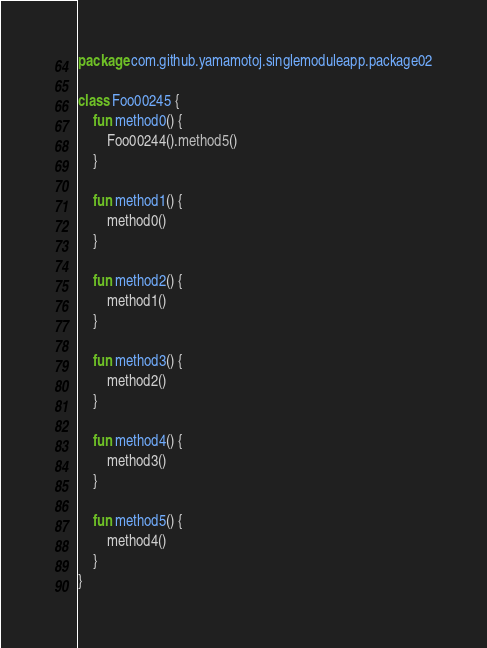Convert code to text. <code><loc_0><loc_0><loc_500><loc_500><_Kotlin_>package com.github.yamamotoj.singlemoduleapp.package02

class Foo00245 {
    fun method0() {
        Foo00244().method5()
    }

    fun method1() {
        method0()
    }

    fun method2() {
        method1()
    }

    fun method3() {
        method2()
    }

    fun method4() {
        method3()
    }

    fun method5() {
        method4()
    }
}
</code> 